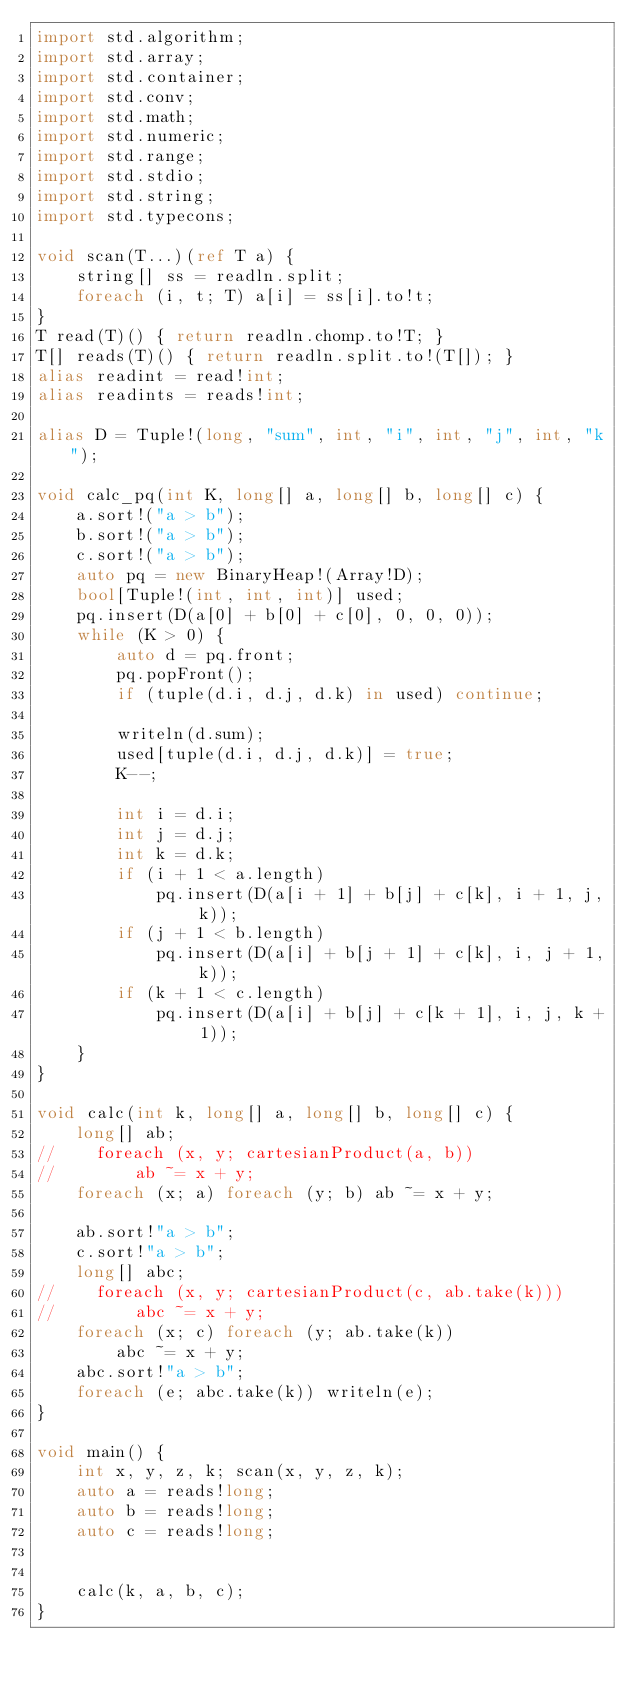<code> <loc_0><loc_0><loc_500><loc_500><_D_>import std.algorithm;
import std.array;
import std.container;
import std.conv;
import std.math;
import std.numeric;
import std.range;
import std.stdio;
import std.string;
import std.typecons;

void scan(T...)(ref T a) {
    string[] ss = readln.split;
    foreach (i, t; T) a[i] = ss[i].to!t;
}
T read(T)() { return readln.chomp.to!T; }
T[] reads(T)() { return readln.split.to!(T[]); }
alias readint = read!int;
alias readints = reads!int;

alias D = Tuple!(long, "sum", int, "i", int, "j", int, "k");

void calc_pq(int K, long[] a, long[] b, long[] c) {
    a.sort!("a > b");
    b.sort!("a > b");
    c.sort!("a > b");
    auto pq = new BinaryHeap!(Array!D);
    bool[Tuple!(int, int, int)] used;
    pq.insert(D(a[0] + b[0] + c[0], 0, 0, 0));
    while (K > 0) {
        auto d = pq.front;
        pq.popFront();
        if (tuple(d.i, d.j, d.k) in used) continue;

        writeln(d.sum);
        used[tuple(d.i, d.j, d.k)] = true;
        K--;

        int i = d.i;
        int j = d.j;
        int k = d.k;
        if (i + 1 < a.length)
            pq.insert(D(a[i + 1] + b[j] + c[k], i + 1, j, k));
        if (j + 1 < b.length)
            pq.insert(D(a[i] + b[j + 1] + c[k], i, j + 1, k));
        if (k + 1 < c.length)
            pq.insert(D(a[i] + b[j] + c[k + 1], i, j, k + 1));
    }
}

void calc(int k, long[] a, long[] b, long[] c) {
    long[] ab;
//    foreach (x, y; cartesianProduct(a, b))
//        ab ~= x + y;
    foreach (x; a) foreach (y; b) ab ~= x + y;

    ab.sort!"a > b";
    c.sort!"a > b";
    long[] abc;
//    foreach (x, y; cartesianProduct(c, ab.take(k)))
//        abc ~= x + y;
    foreach (x; c) foreach (y; ab.take(k))
        abc ~= x + y;
    abc.sort!"a > b";
    foreach (e; abc.take(k)) writeln(e);
}

void main() {
    int x, y, z, k; scan(x, y, z, k);
    auto a = reads!long;
    auto b = reads!long;
    auto c = reads!long;


    calc(k, a, b, c);
}
</code> 